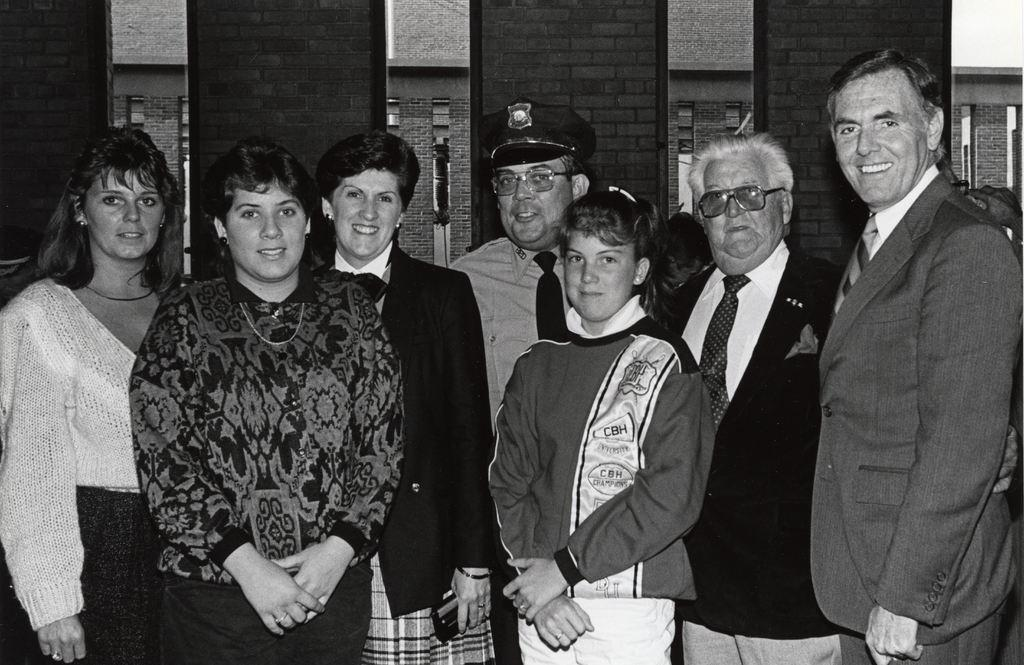What can be seen in the foreground of the image? There is a group of men and women in the image. What are the people in the image doing? The people are standing in the front of the image and smiling. What might be the purpose of their actions in the image? The people are posing for the camera, which suggests they are taking a group photo. What can be seen in the background of the image? There is a brick panel wall in the background of the image. What type of poison is being used by the baby in the image? There is no baby or poison present in the image; it features a group of people posing for a photo. 